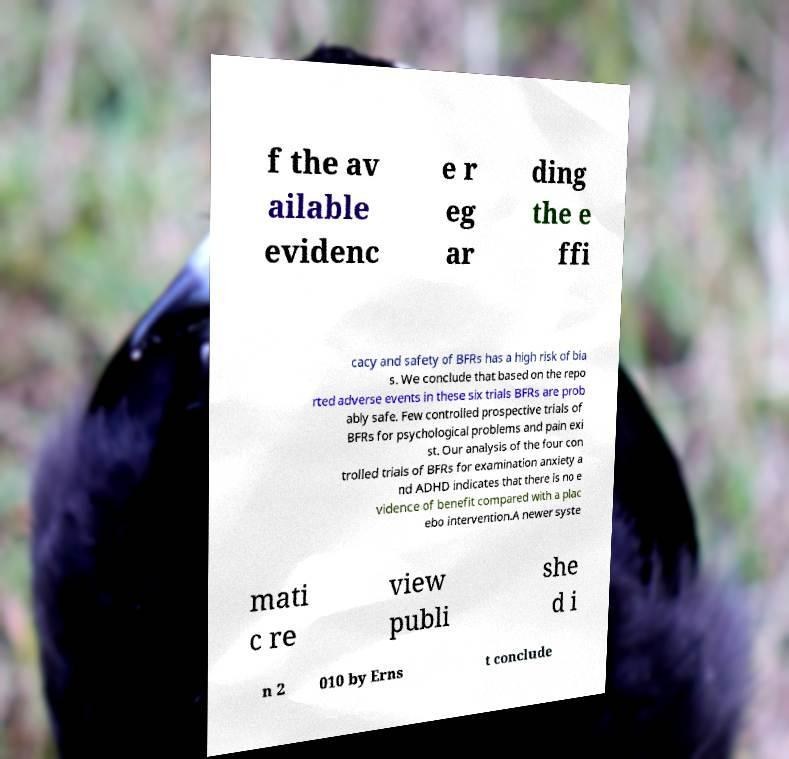Could you extract and type out the text from this image? f the av ailable evidenc e r eg ar ding the e ffi cacy and safety of BFRs has a high risk of bia s. We conclude that based on the repo rted adverse events in these six trials BFRs are prob ably safe. Few controlled prospective trials of BFRs for psychological problems and pain exi st. Our analysis of the four con trolled trials of BFRs for examination anxiety a nd ADHD indicates that there is no e vidence of benefit compared with a plac ebo intervention.A newer syste mati c re view publi she d i n 2 010 by Erns t conclude 